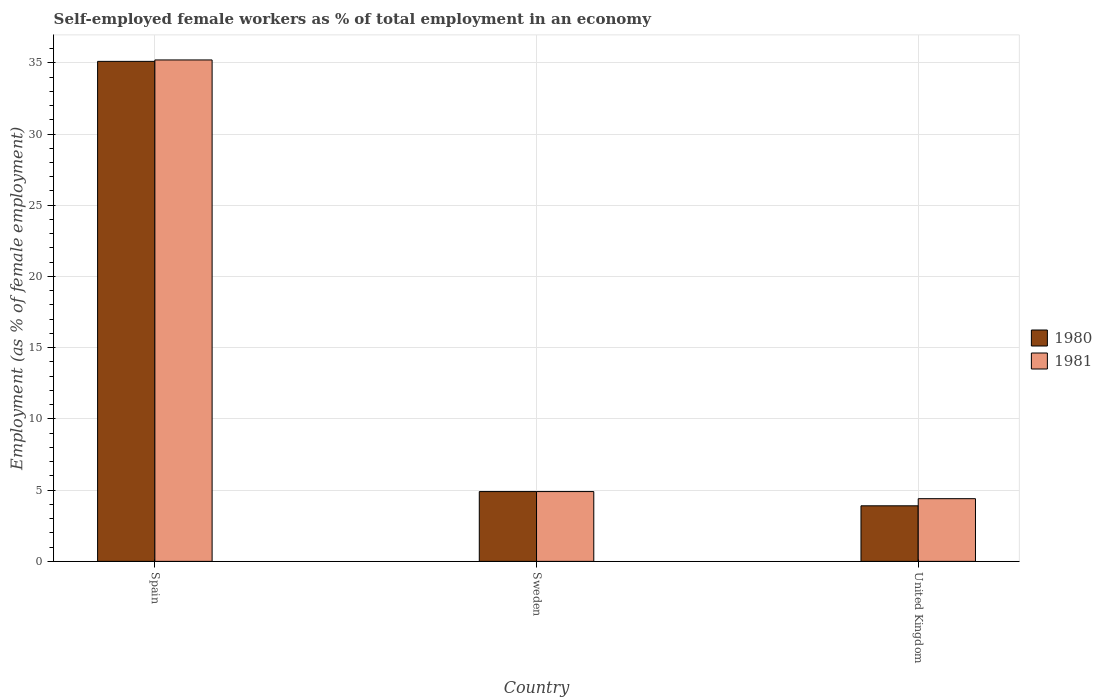How many different coloured bars are there?
Make the answer very short. 2. Are the number of bars per tick equal to the number of legend labels?
Keep it short and to the point. Yes. Are the number of bars on each tick of the X-axis equal?
Make the answer very short. Yes. How many bars are there on the 1st tick from the left?
Offer a terse response. 2. How many bars are there on the 1st tick from the right?
Make the answer very short. 2. In how many cases, is the number of bars for a given country not equal to the number of legend labels?
Make the answer very short. 0. What is the percentage of self-employed female workers in 1981 in Sweden?
Offer a terse response. 4.9. Across all countries, what is the maximum percentage of self-employed female workers in 1980?
Offer a terse response. 35.1. Across all countries, what is the minimum percentage of self-employed female workers in 1981?
Make the answer very short. 4.4. In which country was the percentage of self-employed female workers in 1980 maximum?
Ensure brevity in your answer.  Spain. What is the total percentage of self-employed female workers in 1980 in the graph?
Offer a terse response. 43.9. What is the difference between the percentage of self-employed female workers in 1981 in Spain and that in Sweden?
Give a very brief answer. 30.3. What is the difference between the percentage of self-employed female workers in 1980 in United Kingdom and the percentage of self-employed female workers in 1981 in Spain?
Make the answer very short. -31.3. What is the average percentage of self-employed female workers in 1980 per country?
Give a very brief answer. 14.63. What is the ratio of the percentage of self-employed female workers in 1980 in Spain to that in United Kingdom?
Provide a short and direct response. 9. What is the difference between the highest and the second highest percentage of self-employed female workers in 1980?
Your answer should be very brief. -31.2. What is the difference between the highest and the lowest percentage of self-employed female workers in 1980?
Ensure brevity in your answer.  31.2. What does the 2nd bar from the right in Sweden represents?
Offer a very short reply. 1980. How many bars are there?
Ensure brevity in your answer.  6. How many countries are there in the graph?
Provide a short and direct response. 3. What is the difference between two consecutive major ticks on the Y-axis?
Your response must be concise. 5. Does the graph contain any zero values?
Make the answer very short. No. Does the graph contain grids?
Provide a short and direct response. Yes. Where does the legend appear in the graph?
Offer a terse response. Center right. What is the title of the graph?
Provide a short and direct response. Self-employed female workers as % of total employment in an economy. What is the label or title of the X-axis?
Your response must be concise. Country. What is the label or title of the Y-axis?
Your response must be concise. Employment (as % of female employment). What is the Employment (as % of female employment) in 1980 in Spain?
Offer a terse response. 35.1. What is the Employment (as % of female employment) of 1981 in Spain?
Offer a very short reply. 35.2. What is the Employment (as % of female employment) in 1980 in Sweden?
Make the answer very short. 4.9. What is the Employment (as % of female employment) of 1981 in Sweden?
Keep it short and to the point. 4.9. What is the Employment (as % of female employment) of 1980 in United Kingdom?
Your answer should be very brief. 3.9. What is the Employment (as % of female employment) in 1981 in United Kingdom?
Give a very brief answer. 4.4. Across all countries, what is the maximum Employment (as % of female employment) of 1980?
Your answer should be very brief. 35.1. Across all countries, what is the maximum Employment (as % of female employment) in 1981?
Provide a succinct answer. 35.2. Across all countries, what is the minimum Employment (as % of female employment) in 1980?
Offer a very short reply. 3.9. Across all countries, what is the minimum Employment (as % of female employment) of 1981?
Your response must be concise. 4.4. What is the total Employment (as % of female employment) of 1980 in the graph?
Ensure brevity in your answer.  43.9. What is the total Employment (as % of female employment) in 1981 in the graph?
Provide a succinct answer. 44.5. What is the difference between the Employment (as % of female employment) of 1980 in Spain and that in Sweden?
Offer a terse response. 30.2. What is the difference between the Employment (as % of female employment) in 1981 in Spain and that in Sweden?
Provide a short and direct response. 30.3. What is the difference between the Employment (as % of female employment) of 1980 in Spain and that in United Kingdom?
Offer a very short reply. 31.2. What is the difference between the Employment (as % of female employment) in 1981 in Spain and that in United Kingdom?
Make the answer very short. 30.8. What is the difference between the Employment (as % of female employment) in 1980 in Spain and the Employment (as % of female employment) in 1981 in Sweden?
Give a very brief answer. 30.2. What is the difference between the Employment (as % of female employment) in 1980 in Spain and the Employment (as % of female employment) in 1981 in United Kingdom?
Keep it short and to the point. 30.7. What is the difference between the Employment (as % of female employment) in 1980 in Sweden and the Employment (as % of female employment) in 1981 in United Kingdom?
Make the answer very short. 0.5. What is the average Employment (as % of female employment) in 1980 per country?
Provide a short and direct response. 14.63. What is the average Employment (as % of female employment) of 1981 per country?
Your answer should be compact. 14.83. What is the difference between the Employment (as % of female employment) of 1980 and Employment (as % of female employment) of 1981 in United Kingdom?
Provide a short and direct response. -0.5. What is the ratio of the Employment (as % of female employment) in 1980 in Spain to that in Sweden?
Offer a very short reply. 7.16. What is the ratio of the Employment (as % of female employment) in 1981 in Spain to that in Sweden?
Provide a short and direct response. 7.18. What is the ratio of the Employment (as % of female employment) in 1980 in Spain to that in United Kingdom?
Your response must be concise. 9. What is the ratio of the Employment (as % of female employment) in 1981 in Spain to that in United Kingdom?
Your answer should be very brief. 8. What is the ratio of the Employment (as % of female employment) in 1980 in Sweden to that in United Kingdom?
Your response must be concise. 1.26. What is the ratio of the Employment (as % of female employment) in 1981 in Sweden to that in United Kingdom?
Your answer should be compact. 1.11. What is the difference between the highest and the second highest Employment (as % of female employment) in 1980?
Make the answer very short. 30.2. What is the difference between the highest and the second highest Employment (as % of female employment) in 1981?
Offer a terse response. 30.3. What is the difference between the highest and the lowest Employment (as % of female employment) in 1980?
Your answer should be compact. 31.2. What is the difference between the highest and the lowest Employment (as % of female employment) of 1981?
Keep it short and to the point. 30.8. 